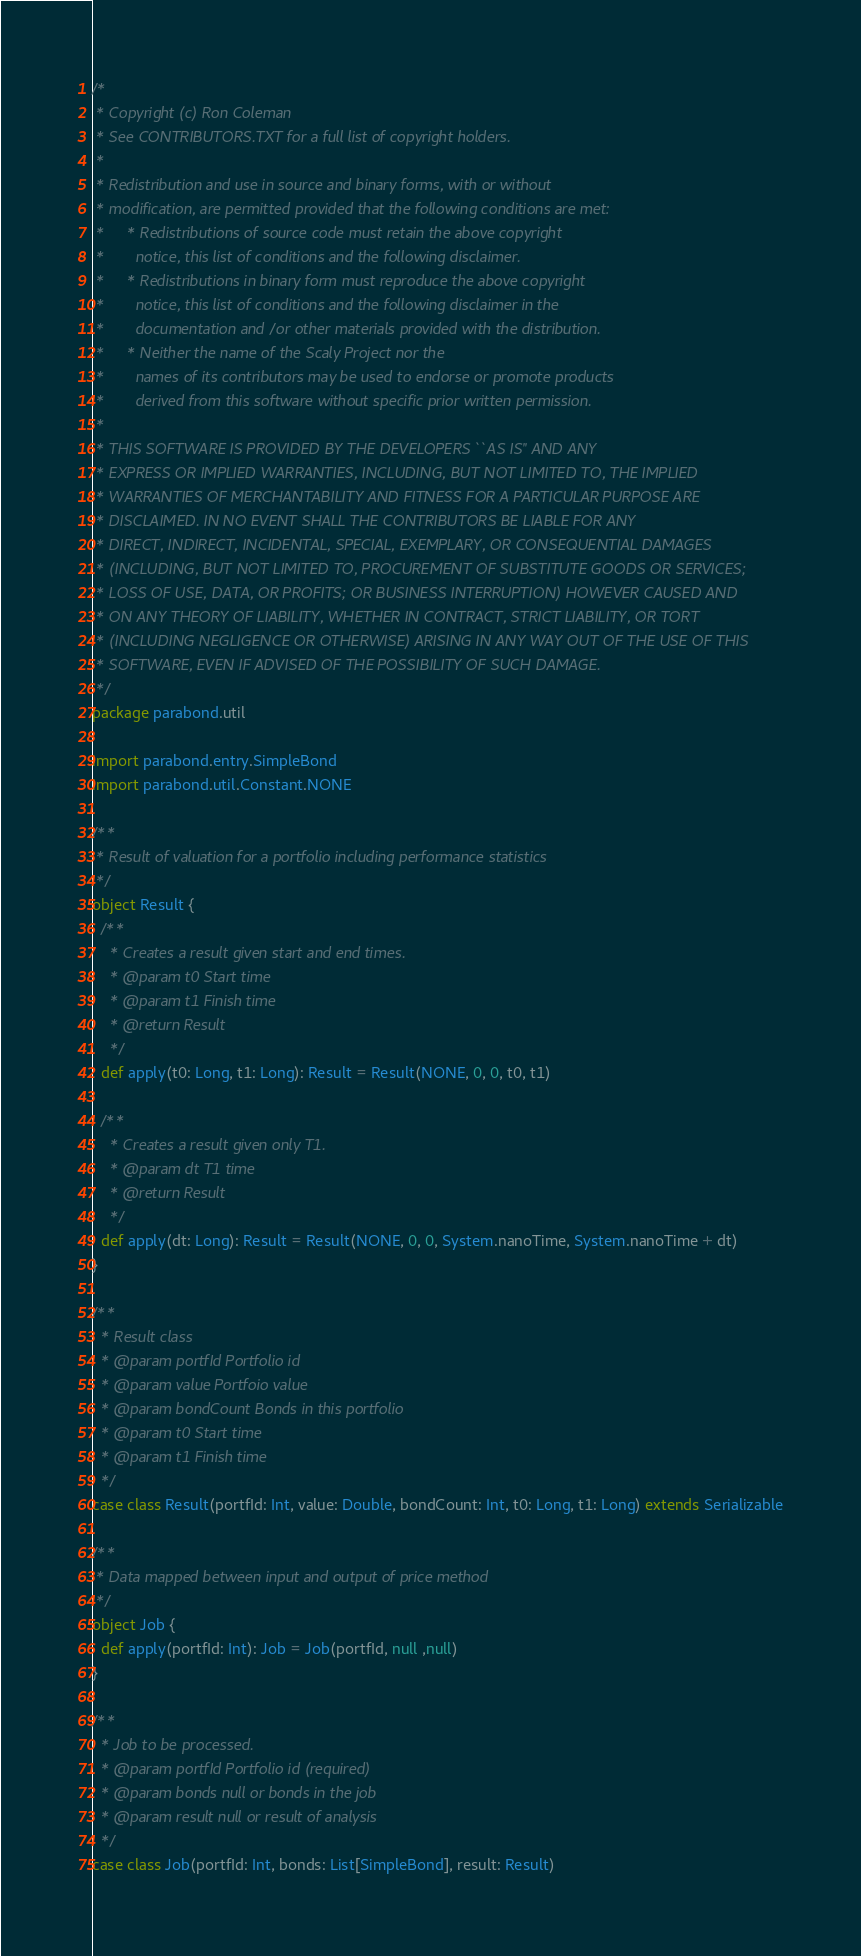<code> <loc_0><loc_0><loc_500><loc_500><_Scala_>/*
 * Copyright (c) Ron Coleman
 * See CONTRIBUTORS.TXT for a full list of copyright holders.
 *
 * Redistribution and use in source and binary forms, with or without
 * modification, are permitted provided that the following conditions are met:
 *     * Redistributions of source code must retain the above copyright
 *       notice, this list of conditions and the following disclaimer.
 *     * Redistributions in binary form must reproduce the above copyright
 *       notice, this list of conditions and the following disclaimer in the
 *       documentation and/or other materials provided with the distribution.
 *     * Neither the name of the Scaly Project nor the
 *       names of its contributors may be used to endorse or promote products
 *       derived from this software without specific prior written permission.
 *
 * THIS SOFTWARE IS PROVIDED BY THE DEVELOPERS ``AS IS'' AND ANY
 * EXPRESS OR IMPLIED WARRANTIES, INCLUDING, BUT NOT LIMITED TO, THE IMPLIED
 * WARRANTIES OF MERCHANTABILITY AND FITNESS FOR A PARTICULAR PURPOSE ARE
 * DISCLAIMED. IN NO EVENT SHALL THE CONTRIBUTORS BE LIABLE FOR ANY
 * DIRECT, INDIRECT, INCIDENTAL, SPECIAL, EXEMPLARY, OR CONSEQUENTIAL DAMAGES
 * (INCLUDING, BUT NOT LIMITED TO, PROCUREMENT OF SUBSTITUTE GOODS OR SERVICES;
 * LOSS OF USE, DATA, OR PROFITS; OR BUSINESS INTERRUPTION) HOWEVER CAUSED AND
 * ON ANY THEORY OF LIABILITY, WHETHER IN CONTRACT, STRICT LIABILITY, OR TORT
 * (INCLUDING NEGLIGENCE OR OTHERWISE) ARISING IN ANY WAY OUT OF THE USE OF THIS
 * SOFTWARE, EVEN IF ADVISED OF THE POSSIBILITY OF SUCH DAMAGE.
 */
package parabond.util

import parabond.entry.SimpleBond
import parabond.util.Constant.NONE

/**
 * Result of valuation for a portfolio including performance statistics
 */
object Result {
  /**
    * Creates a result given start and end times.
    * @param t0 Start time
    * @param t1 Finish time
    * @return Result
    */
  def apply(t0: Long, t1: Long): Result = Result(NONE, 0, 0, t0, t1)

  /**
    * Creates a result given only T1.
    * @param dt T1 time
    * @return Result
    */
  def apply(dt: Long): Result = Result(NONE, 0, 0, System.nanoTime, System.nanoTime + dt)
}

/**
  * Result class
  * @param portfId Portfolio id
  * @param value Portfoio value
  * @param bondCount Bonds in this portfolio
  * @param t0 Start time
  * @param t1 Finish time
  */
case class Result(portfId: Int, value: Double, bondCount: Int, t0: Long, t1: Long) extends Serializable
  
/**
 * Data mapped between input and output of price method
 */
object Job {
  def apply(portfId: Int): Job = Job(portfId, null ,null)
}

/**
  * Job to be processed.
  * @param portfId Portfolio id (required)
  * @param bonds null or bonds in the job
  * @param result null or result of analysis
  */
case class Job(portfId: Int, bonds: List[SimpleBond], result: Result)
</code> 